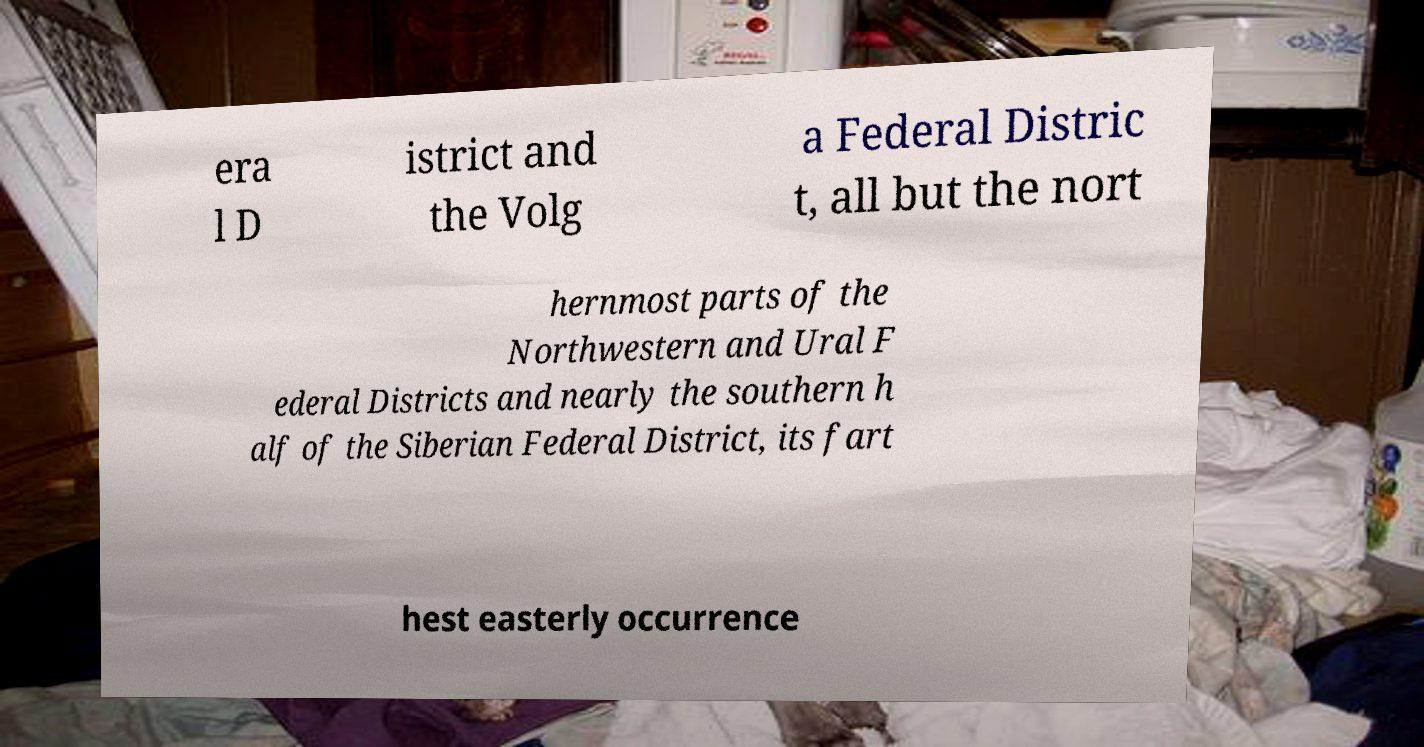Please read and relay the text visible in this image. What does it say? era l D istrict and the Volg a Federal Distric t, all but the nort hernmost parts of the Northwestern and Ural F ederal Districts and nearly the southern h alf of the Siberian Federal District, its fart hest easterly occurrence 